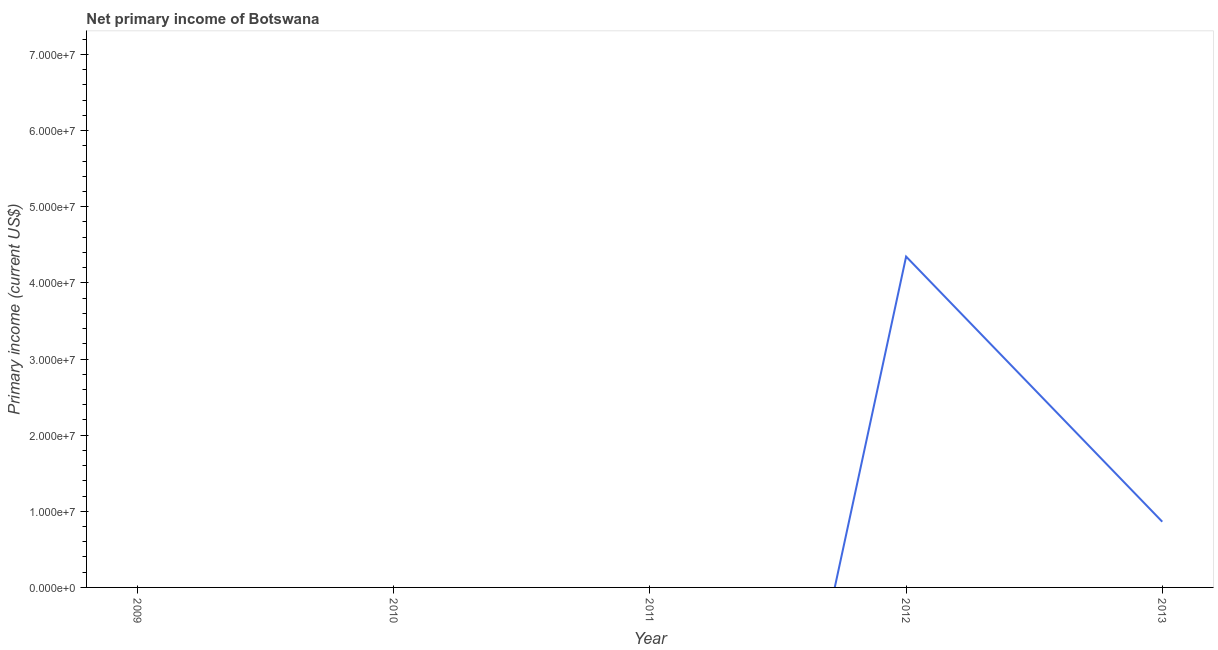Across all years, what is the maximum amount of primary income?
Ensure brevity in your answer.  4.35e+07. Across all years, what is the minimum amount of primary income?
Your answer should be very brief. 0. What is the sum of the amount of primary income?
Offer a very short reply. 5.21e+07. What is the difference between the amount of primary income in 2012 and 2013?
Give a very brief answer. 3.48e+07. What is the average amount of primary income per year?
Offer a very short reply. 1.04e+07. What is the median amount of primary income?
Your answer should be very brief. 0. In how many years, is the amount of primary income greater than 6000000 US$?
Your answer should be very brief. 2. What is the difference between the highest and the lowest amount of primary income?
Your response must be concise. 4.35e+07. In how many years, is the amount of primary income greater than the average amount of primary income taken over all years?
Provide a succinct answer. 1. Does the amount of primary income monotonically increase over the years?
Give a very brief answer. No. How many lines are there?
Your response must be concise. 1. How many years are there in the graph?
Ensure brevity in your answer.  5. Are the values on the major ticks of Y-axis written in scientific E-notation?
Make the answer very short. Yes. Does the graph contain any zero values?
Provide a short and direct response. Yes. Does the graph contain grids?
Your answer should be compact. No. What is the title of the graph?
Your answer should be compact. Net primary income of Botswana. What is the label or title of the X-axis?
Keep it short and to the point. Year. What is the label or title of the Y-axis?
Your answer should be very brief. Primary income (current US$). What is the Primary income (current US$) in 2010?
Your answer should be compact. 0. What is the Primary income (current US$) of 2011?
Give a very brief answer. 0. What is the Primary income (current US$) in 2012?
Offer a terse response. 4.35e+07. What is the Primary income (current US$) of 2013?
Provide a succinct answer. 8.63e+06. What is the difference between the Primary income (current US$) in 2012 and 2013?
Offer a very short reply. 3.48e+07. What is the ratio of the Primary income (current US$) in 2012 to that in 2013?
Your response must be concise. 5.03. 